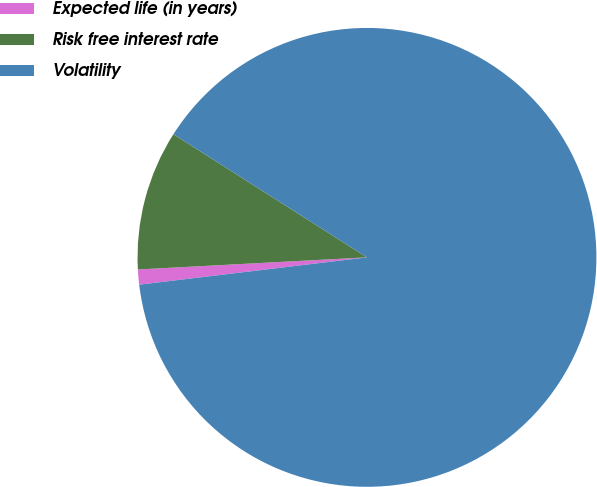Convert chart. <chart><loc_0><loc_0><loc_500><loc_500><pie_chart><fcel>Expected life (in years)<fcel>Risk free interest rate<fcel>Volatility<nl><fcel>1.06%<fcel>9.86%<fcel>89.08%<nl></chart> 